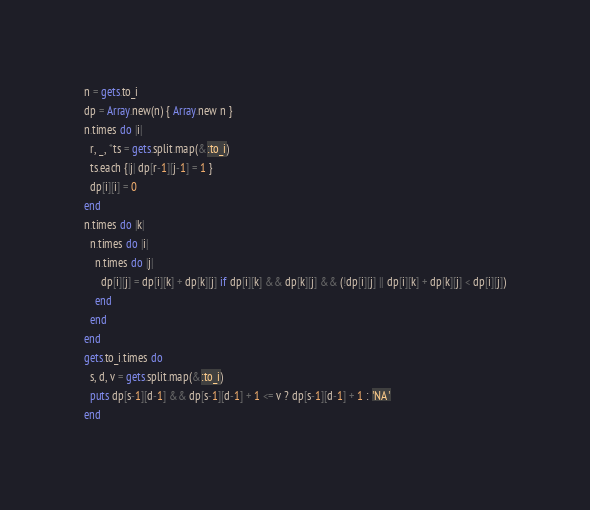Convert code to text. <code><loc_0><loc_0><loc_500><loc_500><_Ruby_>n = gets.to_i
dp = Array.new(n) { Array.new n }
n.times do |i|
  r, _, *ts = gets.split.map(&:to_i)
  ts.each {|j| dp[r-1][j-1] = 1 }
  dp[i][i] = 0
end
n.times do |k|
  n.times do |i|
    n.times do |j|
      dp[i][j] = dp[i][k] + dp[k][j] if dp[i][k] && dp[k][j] && (!dp[i][j] || dp[i][k] + dp[k][j] < dp[i][j])
    end
  end
end
gets.to_i.times do
  s, d, v = gets.split.map(&:to_i)
  puts dp[s-1][d-1] && dp[s-1][d-1] + 1 <= v ? dp[s-1][d-1] + 1 : 'NA'
end</code> 